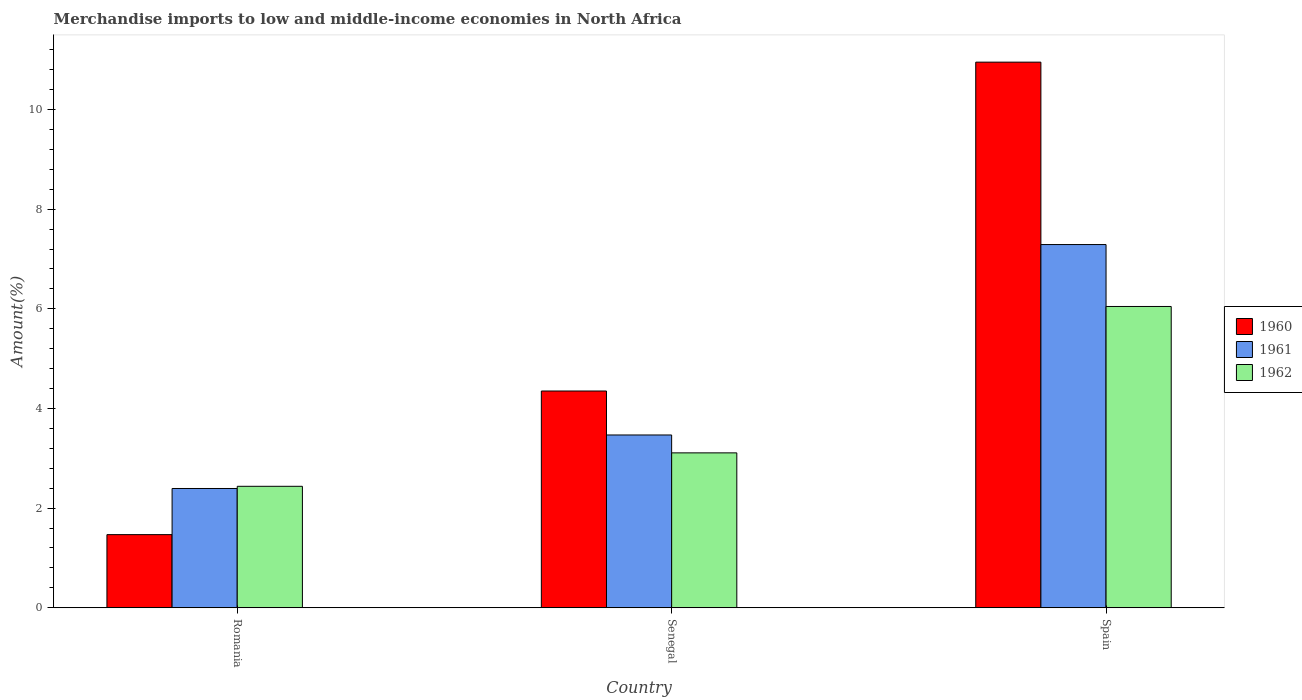How many different coloured bars are there?
Offer a very short reply. 3. Are the number of bars on each tick of the X-axis equal?
Make the answer very short. Yes. How many bars are there on the 1st tick from the left?
Provide a succinct answer. 3. What is the label of the 1st group of bars from the left?
Your answer should be very brief. Romania. In how many cases, is the number of bars for a given country not equal to the number of legend labels?
Offer a terse response. 0. What is the percentage of amount earned from merchandise imports in 1961 in Senegal?
Ensure brevity in your answer.  3.47. Across all countries, what is the maximum percentage of amount earned from merchandise imports in 1962?
Your answer should be very brief. 6.05. Across all countries, what is the minimum percentage of amount earned from merchandise imports in 1961?
Make the answer very short. 2.39. In which country was the percentage of amount earned from merchandise imports in 1961 maximum?
Your answer should be compact. Spain. In which country was the percentage of amount earned from merchandise imports in 1962 minimum?
Ensure brevity in your answer.  Romania. What is the total percentage of amount earned from merchandise imports in 1961 in the graph?
Your answer should be very brief. 13.15. What is the difference between the percentage of amount earned from merchandise imports in 1961 in Romania and that in Spain?
Provide a succinct answer. -4.9. What is the difference between the percentage of amount earned from merchandise imports in 1961 in Spain and the percentage of amount earned from merchandise imports in 1960 in Senegal?
Your answer should be compact. 2.94. What is the average percentage of amount earned from merchandise imports in 1961 per country?
Give a very brief answer. 4.38. What is the difference between the percentage of amount earned from merchandise imports of/in 1961 and percentage of amount earned from merchandise imports of/in 1962 in Romania?
Provide a succinct answer. -0.04. What is the ratio of the percentage of amount earned from merchandise imports in 1962 in Romania to that in Senegal?
Offer a very short reply. 0.78. Is the percentage of amount earned from merchandise imports in 1960 in Romania less than that in Senegal?
Your response must be concise. Yes. Is the difference between the percentage of amount earned from merchandise imports in 1961 in Senegal and Spain greater than the difference between the percentage of amount earned from merchandise imports in 1962 in Senegal and Spain?
Provide a succinct answer. No. What is the difference between the highest and the second highest percentage of amount earned from merchandise imports in 1960?
Give a very brief answer. -9.48. What is the difference between the highest and the lowest percentage of amount earned from merchandise imports in 1961?
Ensure brevity in your answer.  4.9. What does the 2nd bar from the left in Romania represents?
Ensure brevity in your answer.  1961. What does the 3rd bar from the right in Spain represents?
Make the answer very short. 1960. How many bars are there?
Provide a succinct answer. 9. Are all the bars in the graph horizontal?
Offer a very short reply. No. How many countries are there in the graph?
Keep it short and to the point. 3. What is the difference between two consecutive major ticks on the Y-axis?
Offer a very short reply. 2. How are the legend labels stacked?
Keep it short and to the point. Vertical. What is the title of the graph?
Give a very brief answer. Merchandise imports to low and middle-income economies in North Africa. What is the label or title of the Y-axis?
Make the answer very short. Amount(%). What is the Amount(%) of 1960 in Romania?
Offer a very short reply. 1.47. What is the Amount(%) in 1961 in Romania?
Your answer should be very brief. 2.39. What is the Amount(%) of 1962 in Romania?
Offer a very short reply. 2.44. What is the Amount(%) of 1960 in Senegal?
Your response must be concise. 4.35. What is the Amount(%) of 1961 in Senegal?
Offer a terse response. 3.47. What is the Amount(%) of 1962 in Senegal?
Provide a succinct answer. 3.11. What is the Amount(%) in 1960 in Spain?
Your answer should be compact. 10.95. What is the Amount(%) of 1961 in Spain?
Keep it short and to the point. 7.29. What is the Amount(%) of 1962 in Spain?
Make the answer very short. 6.05. Across all countries, what is the maximum Amount(%) of 1960?
Make the answer very short. 10.95. Across all countries, what is the maximum Amount(%) of 1961?
Give a very brief answer. 7.29. Across all countries, what is the maximum Amount(%) of 1962?
Provide a succinct answer. 6.05. Across all countries, what is the minimum Amount(%) of 1960?
Provide a short and direct response. 1.47. Across all countries, what is the minimum Amount(%) in 1961?
Keep it short and to the point. 2.39. Across all countries, what is the minimum Amount(%) in 1962?
Your answer should be compact. 2.44. What is the total Amount(%) of 1960 in the graph?
Offer a very short reply. 16.77. What is the total Amount(%) in 1961 in the graph?
Keep it short and to the point. 13.15. What is the total Amount(%) of 1962 in the graph?
Offer a terse response. 11.59. What is the difference between the Amount(%) of 1960 in Romania and that in Senegal?
Offer a terse response. -2.88. What is the difference between the Amount(%) of 1961 in Romania and that in Senegal?
Provide a short and direct response. -1.07. What is the difference between the Amount(%) in 1962 in Romania and that in Senegal?
Provide a succinct answer. -0.67. What is the difference between the Amount(%) of 1960 in Romania and that in Spain?
Ensure brevity in your answer.  -9.48. What is the difference between the Amount(%) in 1961 in Romania and that in Spain?
Make the answer very short. -4.9. What is the difference between the Amount(%) of 1962 in Romania and that in Spain?
Keep it short and to the point. -3.61. What is the difference between the Amount(%) of 1960 in Senegal and that in Spain?
Offer a very short reply. -6.6. What is the difference between the Amount(%) of 1961 in Senegal and that in Spain?
Keep it short and to the point. -3.82. What is the difference between the Amount(%) in 1962 in Senegal and that in Spain?
Keep it short and to the point. -2.94. What is the difference between the Amount(%) of 1960 in Romania and the Amount(%) of 1961 in Senegal?
Keep it short and to the point. -2. What is the difference between the Amount(%) of 1960 in Romania and the Amount(%) of 1962 in Senegal?
Keep it short and to the point. -1.64. What is the difference between the Amount(%) of 1961 in Romania and the Amount(%) of 1962 in Senegal?
Give a very brief answer. -0.71. What is the difference between the Amount(%) in 1960 in Romania and the Amount(%) in 1961 in Spain?
Your answer should be compact. -5.82. What is the difference between the Amount(%) in 1960 in Romania and the Amount(%) in 1962 in Spain?
Provide a succinct answer. -4.58. What is the difference between the Amount(%) of 1961 in Romania and the Amount(%) of 1962 in Spain?
Offer a very short reply. -3.65. What is the difference between the Amount(%) of 1960 in Senegal and the Amount(%) of 1961 in Spain?
Provide a short and direct response. -2.94. What is the difference between the Amount(%) of 1960 in Senegal and the Amount(%) of 1962 in Spain?
Give a very brief answer. -1.7. What is the difference between the Amount(%) of 1961 in Senegal and the Amount(%) of 1962 in Spain?
Your answer should be very brief. -2.58. What is the average Amount(%) in 1960 per country?
Offer a very short reply. 5.59. What is the average Amount(%) in 1961 per country?
Ensure brevity in your answer.  4.38. What is the average Amount(%) in 1962 per country?
Provide a succinct answer. 3.86. What is the difference between the Amount(%) of 1960 and Amount(%) of 1961 in Romania?
Provide a short and direct response. -0.93. What is the difference between the Amount(%) of 1960 and Amount(%) of 1962 in Romania?
Your response must be concise. -0.97. What is the difference between the Amount(%) in 1961 and Amount(%) in 1962 in Romania?
Provide a succinct answer. -0.04. What is the difference between the Amount(%) in 1960 and Amount(%) in 1961 in Senegal?
Give a very brief answer. 0.88. What is the difference between the Amount(%) of 1960 and Amount(%) of 1962 in Senegal?
Your answer should be very brief. 1.24. What is the difference between the Amount(%) in 1961 and Amount(%) in 1962 in Senegal?
Ensure brevity in your answer.  0.36. What is the difference between the Amount(%) of 1960 and Amount(%) of 1961 in Spain?
Provide a short and direct response. 3.66. What is the difference between the Amount(%) in 1960 and Amount(%) in 1962 in Spain?
Provide a short and direct response. 4.9. What is the difference between the Amount(%) in 1961 and Amount(%) in 1962 in Spain?
Keep it short and to the point. 1.24. What is the ratio of the Amount(%) in 1960 in Romania to that in Senegal?
Offer a terse response. 0.34. What is the ratio of the Amount(%) in 1961 in Romania to that in Senegal?
Make the answer very short. 0.69. What is the ratio of the Amount(%) in 1962 in Romania to that in Senegal?
Give a very brief answer. 0.78. What is the ratio of the Amount(%) of 1960 in Romania to that in Spain?
Your answer should be very brief. 0.13. What is the ratio of the Amount(%) of 1961 in Romania to that in Spain?
Your response must be concise. 0.33. What is the ratio of the Amount(%) of 1962 in Romania to that in Spain?
Ensure brevity in your answer.  0.4. What is the ratio of the Amount(%) of 1960 in Senegal to that in Spain?
Keep it short and to the point. 0.4. What is the ratio of the Amount(%) of 1961 in Senegal to that in Spain?
Provide a short and direct response. 0.48. What is the ratio of the Amount(%) of 1962 in Senegal to that in Spain?
Ensure brevity in your answer.  0.51. What is the difference between the highest and the second highest Amount(%) of 1960?
Provide a succinct answer. 6.6. What is the difference between the highest and the second highest Amount(%) in 1961?
Your answer should be compact. 3.82. What is the difference between the highest and the second highest Amount(%) in 1962?
Give a very brief answer. 2.94. What is the difference between the highest and the lowest Amount(%) in 1960?
Offer a very short reply. 9.48. What is the difference between the highest and the lowest Amount(%) in 1961?
Give a very brief answer. 4.9. What is the difference between the highest and the lowest Amount(%) of 1962?
Make the answer very short. 3.61. 